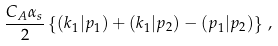<formula> <loc_0><loc_0><loc_500><loc_500>\frac { C _ { A } \alpha _ { s } } { 2 } \left \{ ( k _ { 1 } | p _ { 1 } ) + ( k _ { 1 } | p _ { 2 } ) - ( p _ { 1 } | p _ { 2 } ) \right \} \, ,</formula> 